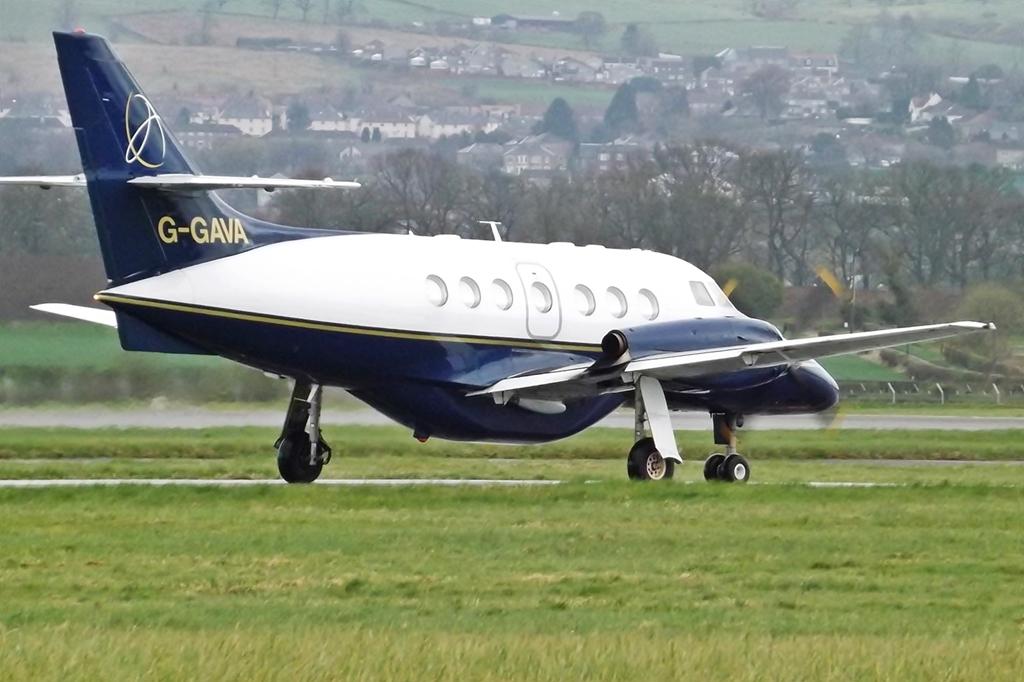What is on the tail?
Give a very brief answer. G-gava. 